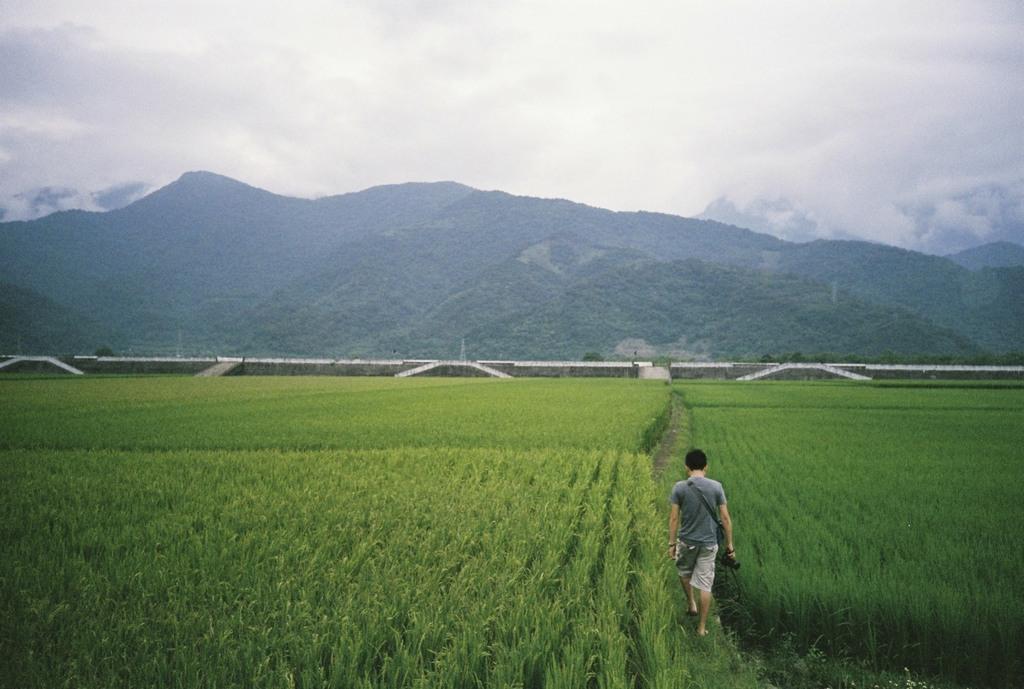In one or two sentences, can you explain what this image depicts? There is a field. A person is holding a camera and walking. In the back there are hills. In the background it is white. 